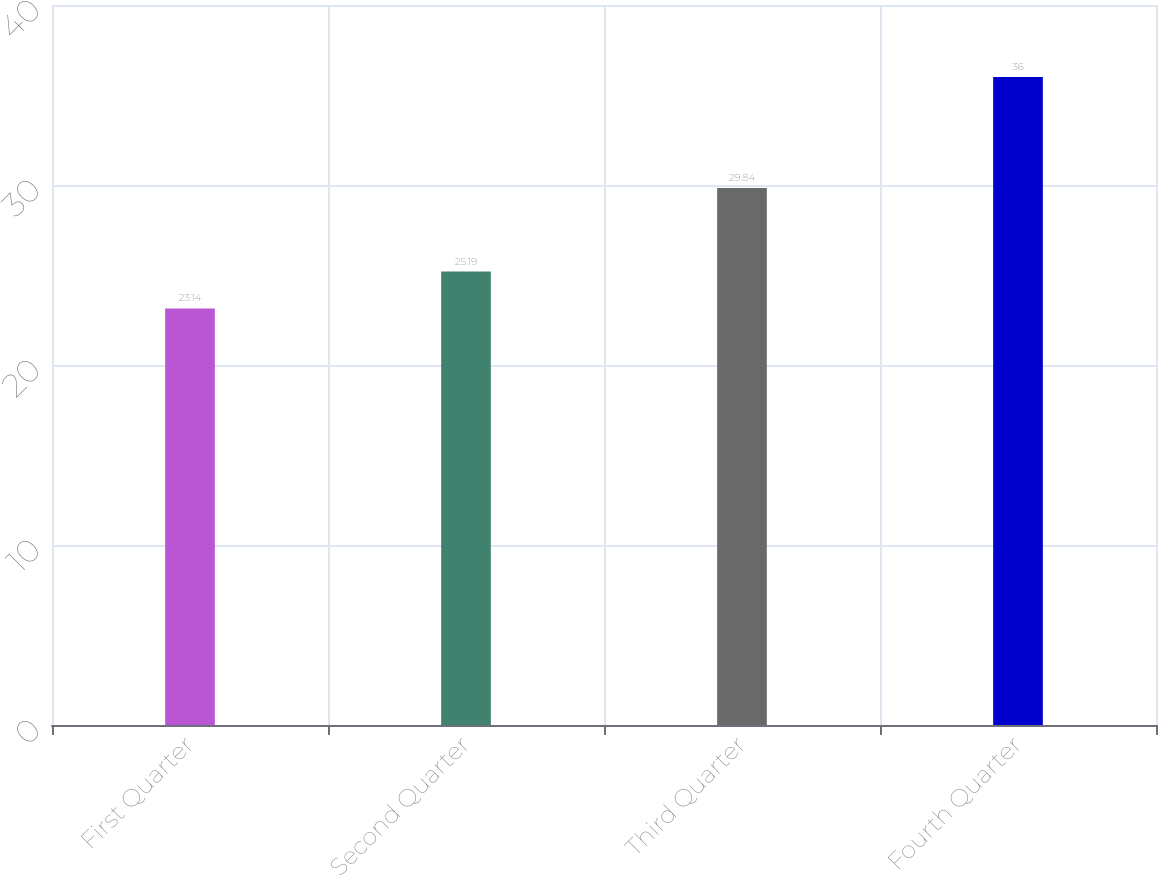Convert chart. <chart><loc_0><loc_0><loc_500><loc_500><bar_chart><fcel>First Quarter<fcel>Second Quarter<fcel>Third Quarter<fcel>Fourth Quarter<nl><fcel>23.14<fcel>25.19<fcel>29.84<fcel>36<nl></chart> 